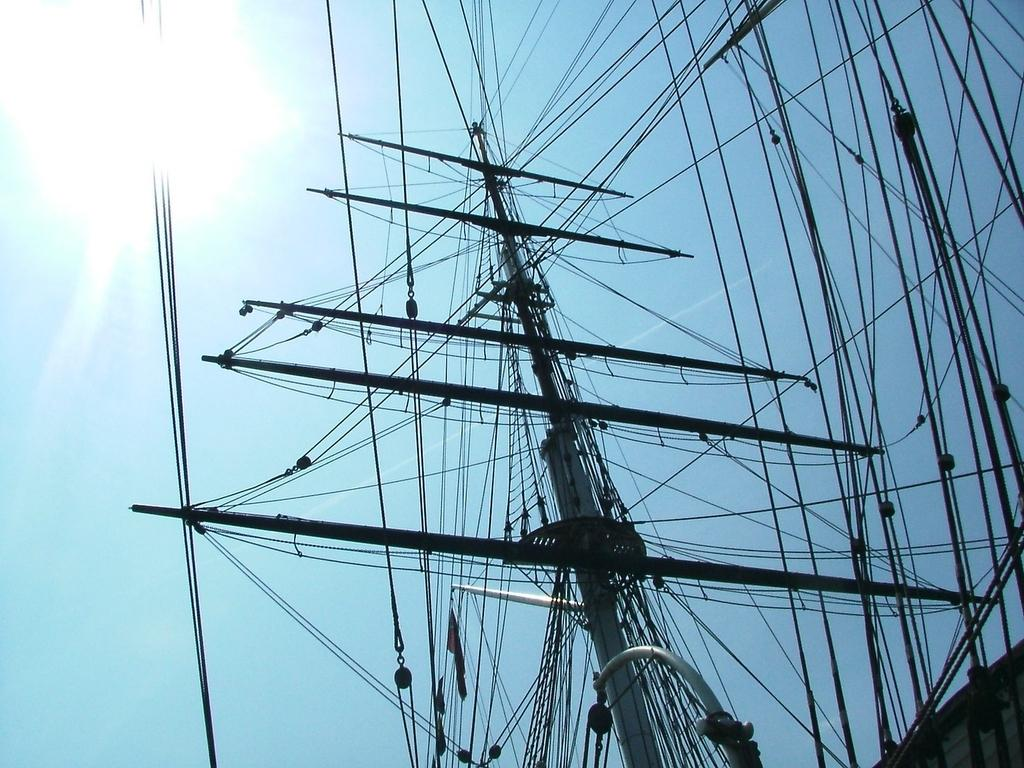What is the main object in the image? There is a pole in the image. Are there any other objects related to the pole? Yes, there are wires in the image. What can be seen in the background of the image? The sky is visible in the background of the image. What type of destruction can be seen happening to the pole in the image? There is no destruction happening to the pole in the image; it appears to be standing upright. 